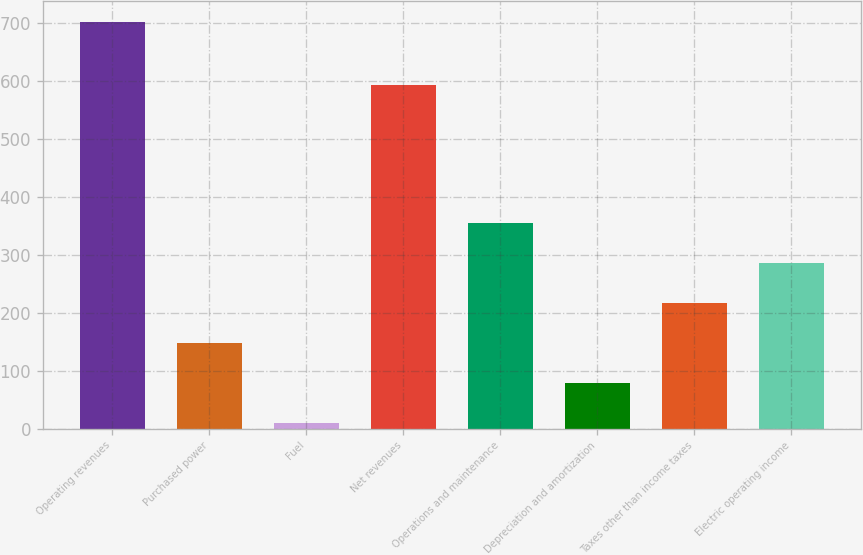<chart> <loc_0><loc_0><loc_500><loc_500><bar_chart><fcel>Operating revenues<fcel>Purchased power<fcel>Fuel<fcel>Net revenues<fcel>Operations and maintenance<fcel>Depreciation and amortization<fcel>Taxes other than income taxes<fcel>Electric operating income<nl><fcel>702<fcel>147.6<fcel>9<fcel>593<fcel>355.5<fcel>78.3<fcel>216.9<fcel>286.2<nl></chart> 